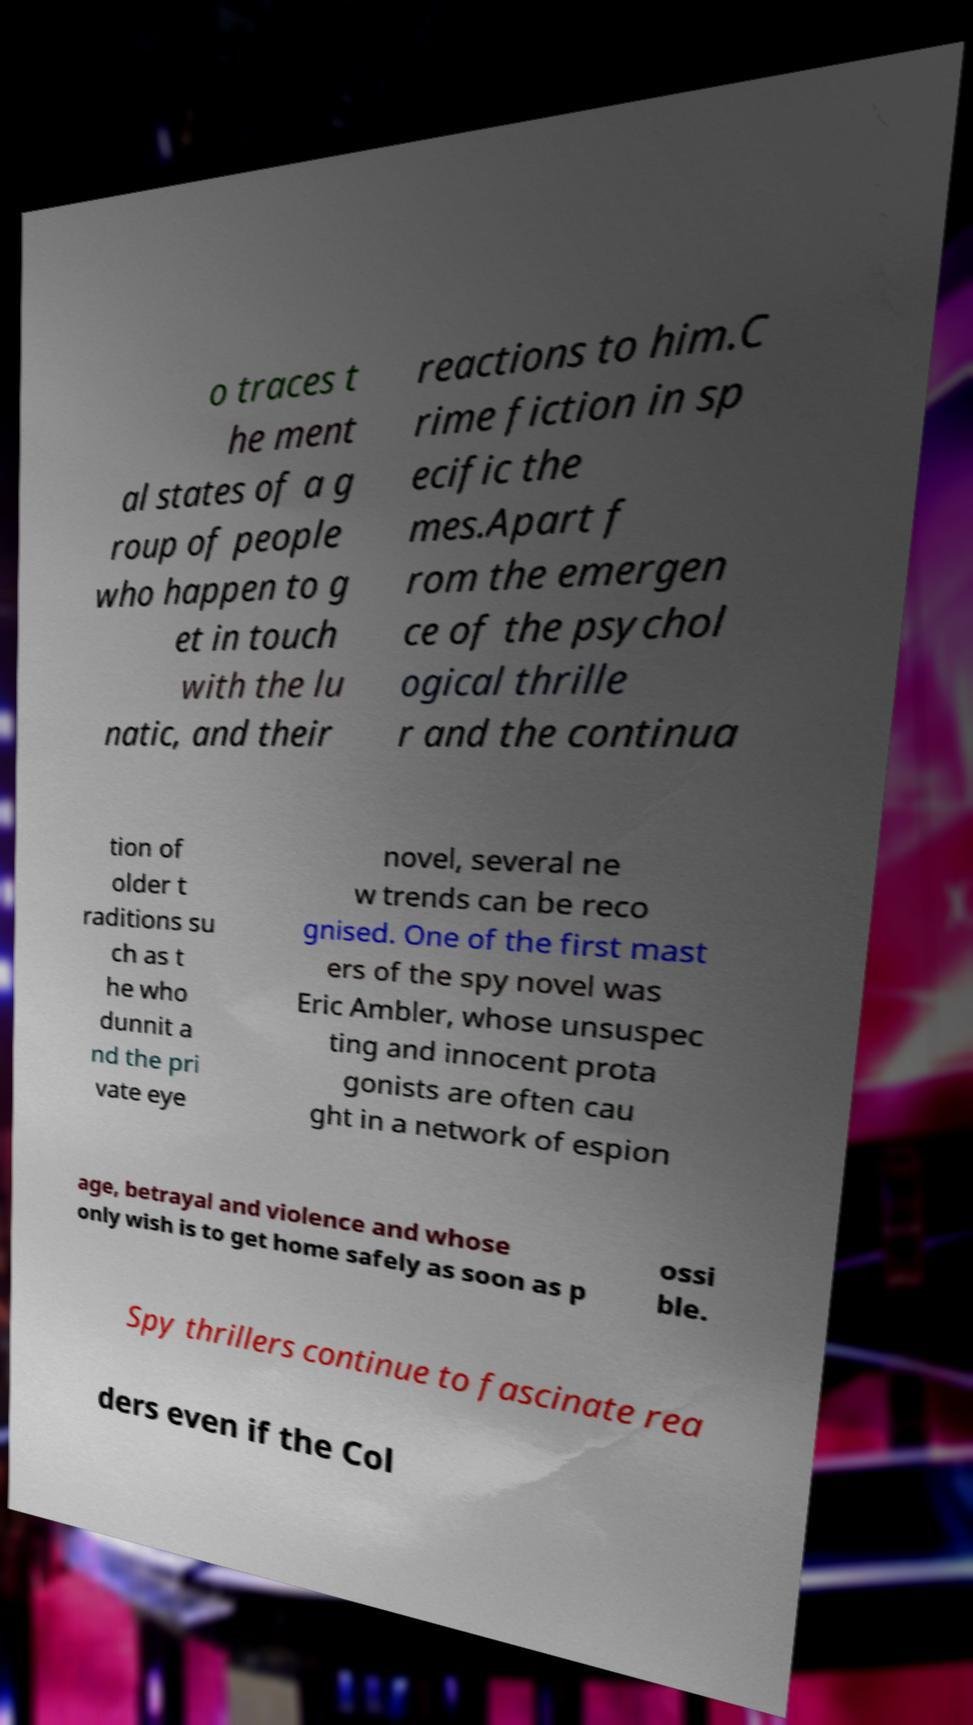Could you extract and type out the text from this image? o traces t he ment al states of a g roup of people who happen to g et in touch with the lu natic, and their reactions to him.C rime fiction in sp ecific the mes.Apart f rom the emergen ce of the psychol ogical thrille r and the continua tion of older t raditions su ch as t he who dunnit a nd the pri vate eye novel, several ne w trends can be reco gnised. One of the first mast ers of the spy novel was Eric Ambler, whose unsuspec ting and innocent prota gonists are often cau ght in a network of espion age, betrayal and violence and whose only wish is to get home safely as soon as p ossi ble. Spy thrillers continue to fascinate rea ders even if the Col 